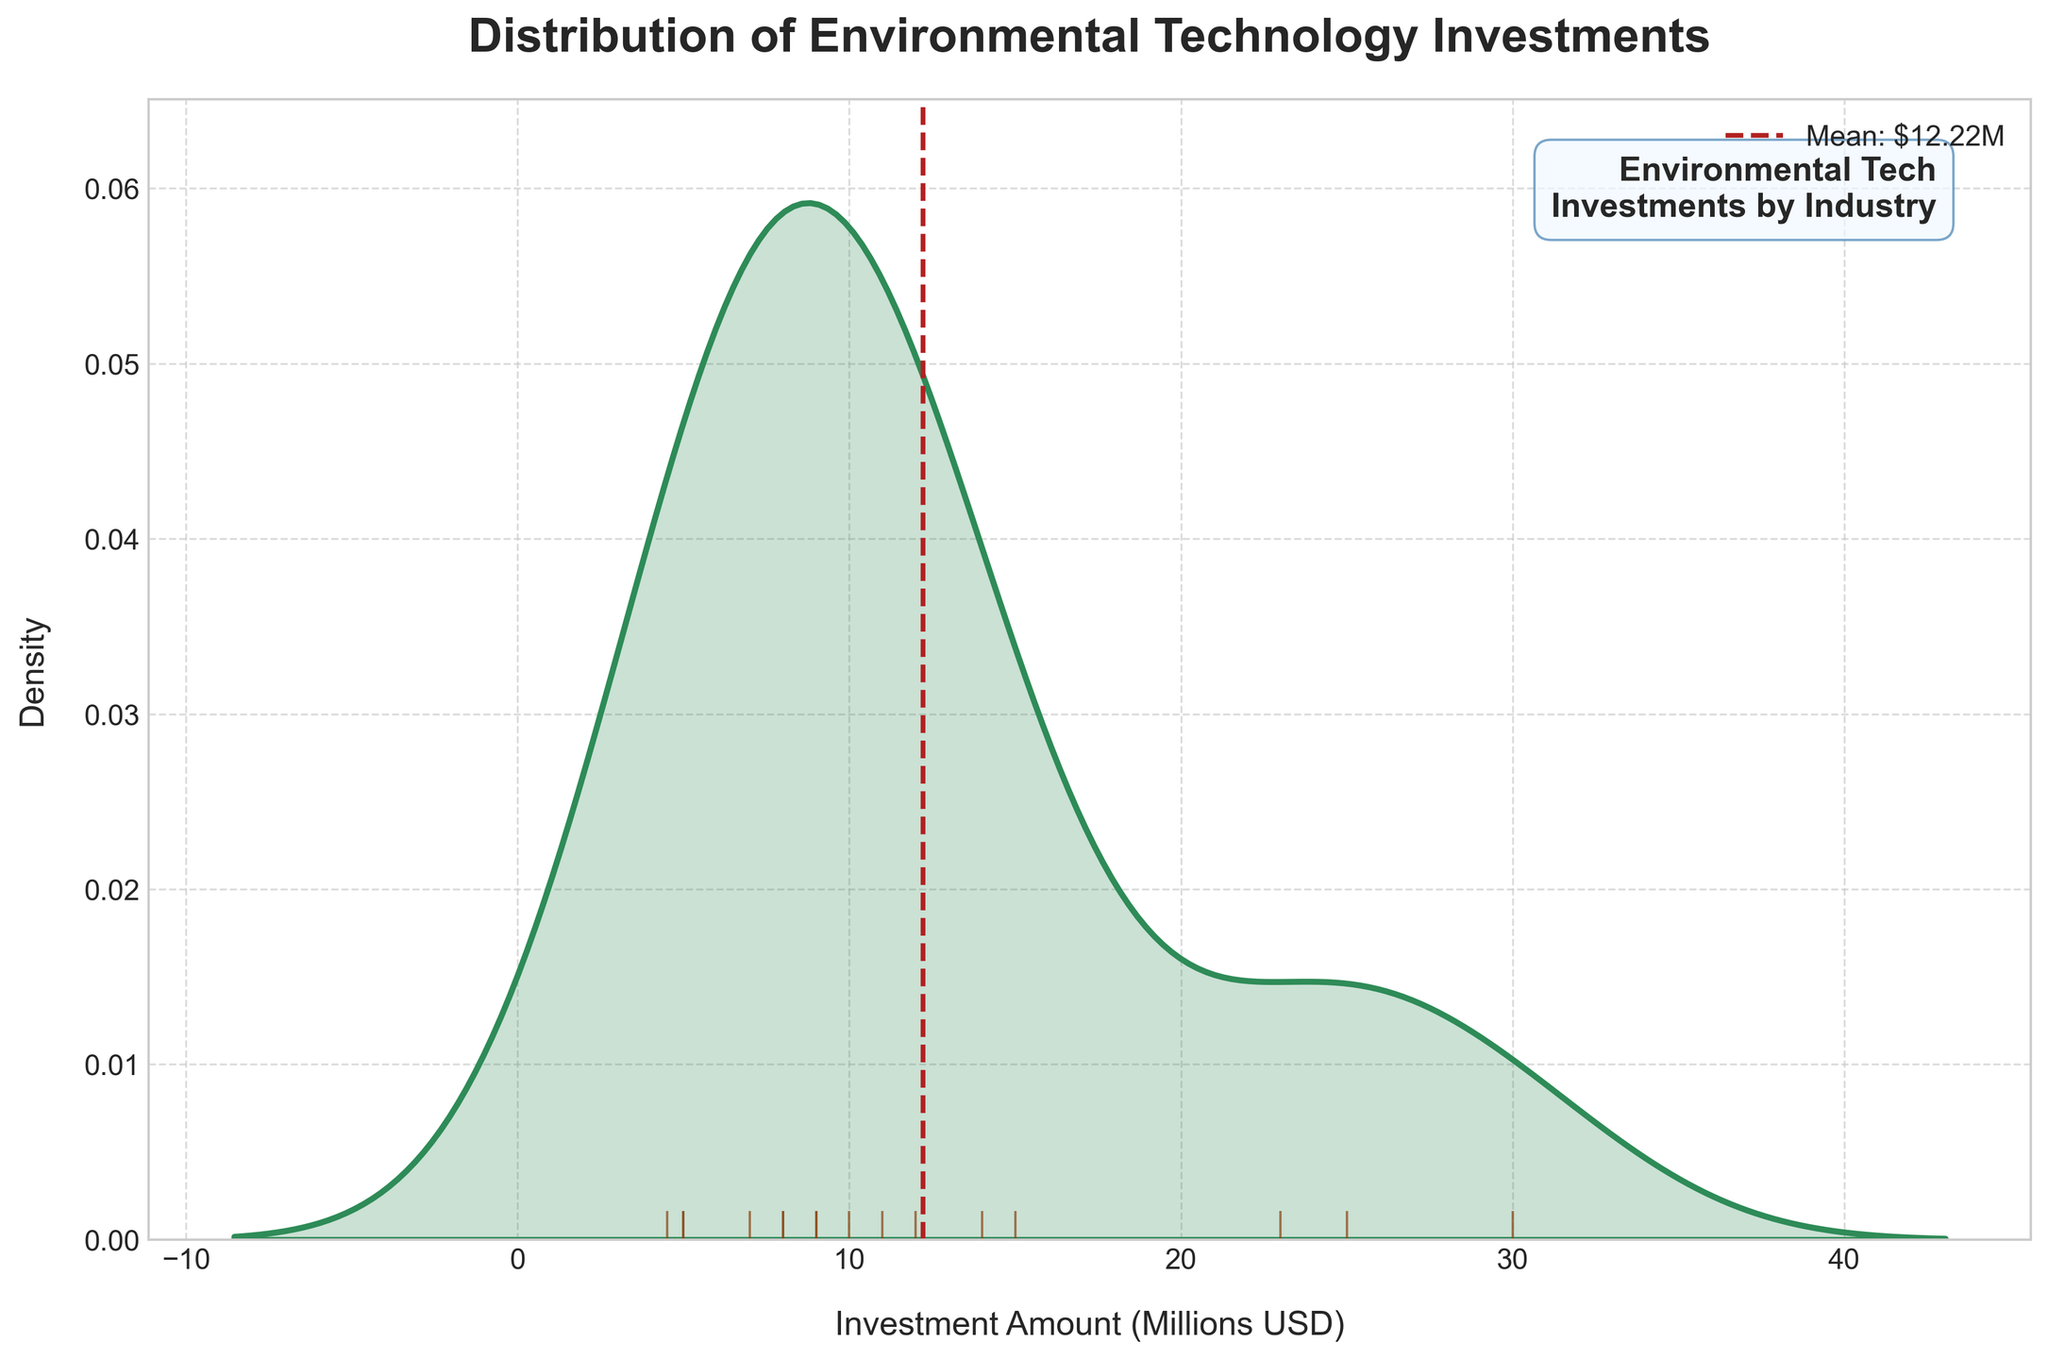What is the title of the plot? The title of the plot is displayed at the top-centre part of the image. It reads "Distribution of Environmental Technology Investments."
Answer: Distribution of Environmental Technology Investments What is the unit of the x-axis? The x-axis label can be found below the horizontal axis. It states "Investment Amount (Millions USD)," indicating the unit is millions of USD.
Answer: Millions USD How many distinct peak(s) are there in the density plot? By examining the contour and peaks of the distribution curve, you can see that there are two noticeable peaks. These represent the most frequently occurring investment amounts.
Answer: 2 What is the mean investment amount? There is a vertical dashed red line on the plot, representing the mean. The legend attached to the line indicates the value. The mean is identified as "Mean: $13.93M."
Answer: $13.93M What is the range of the investment amounts shown in the rug plot? To determine the range, look at the horizontal rug plot at the bottom, which marks the lowest and highest points. The minimum is approximately 4.5 million, and the maximum is about 30 million USD.
Answer: 4.5 million to 30 million USD Which sector has the largest investment represented in the figure? From the data provided, Google from the Technology sector has the largest investment, as seen from its position relative to other sectors.
Answer: Technology How does the mean investment amount compare to the median investment amount? The mean investment is visually represented by the vertical red dashed line. The median would be approximately the value where the area under the curve is equally divided, which appears to be close but slightly lower than the mean.
Answer: Mean is slightly higher than the median Which sector is likely to have the smallest average investment based on the density plot? Industries with lower contributions will affect the density, typically visible with smaller peaks on the distribution. Transportation and Energy sectors have lower individual investments, hinting at smaller average investments.
Answer: Transportation or Energy What is the difference between the highest and the lowest investment amounts? From the rug plot, the highest investment appears near 30 million dollars and the lowest near 4.5 million dollars. The difference can be calculated as 30 minus 4.5.
Answer: 25.5 million USD 